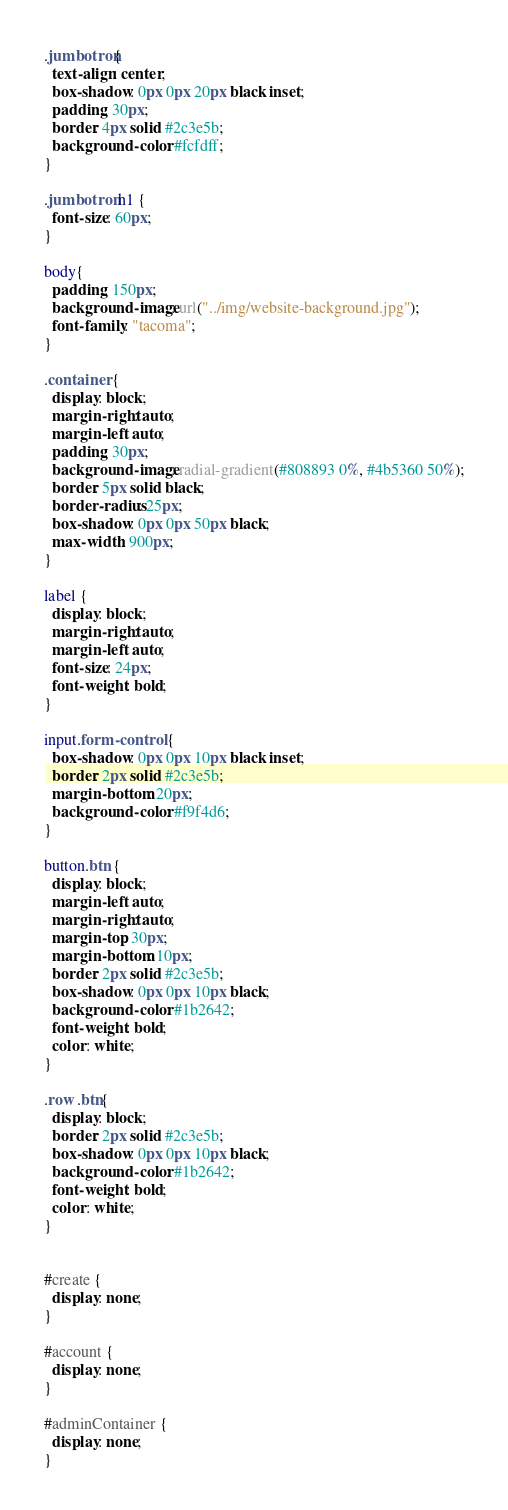<code> <loc_0><loc_0><loc_500><loc_500><_CSS_>.jumbotron{
  text-align: center;
  box-shadow: 0px 0px 20px black inset;
  padding: 30px;
  border: 4px solid #2c3e5b;
  background-color: #fcfdff;
}

.jumbotron h1 {
  font-size: 60px;
}

body{
  padding: 150px;
  background-image: url("../img/website-background.jpg");
  font-family: "tacoma";
}

.container {
  display: block;
  margin-right: auto;
  margin-left: auto;
  padding: 30px;
  background-image: radial-gradient(#808893 0%, #4b5360 50%);
  border: 5px solid black;
  border-radius: 25px;
  box-shadow: 0px 0px 50px black;
  max-width: 900px;
}

label {
  display: block;
  margin-right: auto;
  margin-left: auto;
  font-size: 24px;
  font-weight: bold;
}

input.form-control {
  box-shadow: 0px 0px 10px black inset;
  border: 2px solid #2c3e5b;
  margin-bottom: 20px;
  background-color: #f9f4d6;
}

button.btn {
  display: block;
  margin-left: auto;
  margin-right: auto;
  margin-top: 30px;
  margin-bottom: 10px;
  border: 2px solid #2c3e5b;
  box-shadow: 0px 0px 10px black;
  background-color: #1b2642;
  font-weight: bold;
  color: white;
}

.row .btn{
  display: block;
  border: 2px solid #2c3e5b;
  box-shadow: 0px 0px 10px black;
  background-color: #1b2642;
  font-weight: bold;
  color: white;
}


#create {
  display: none;
}

#account {
  display: none;
}

#adminContainer {
  display: none;
}
</code> 